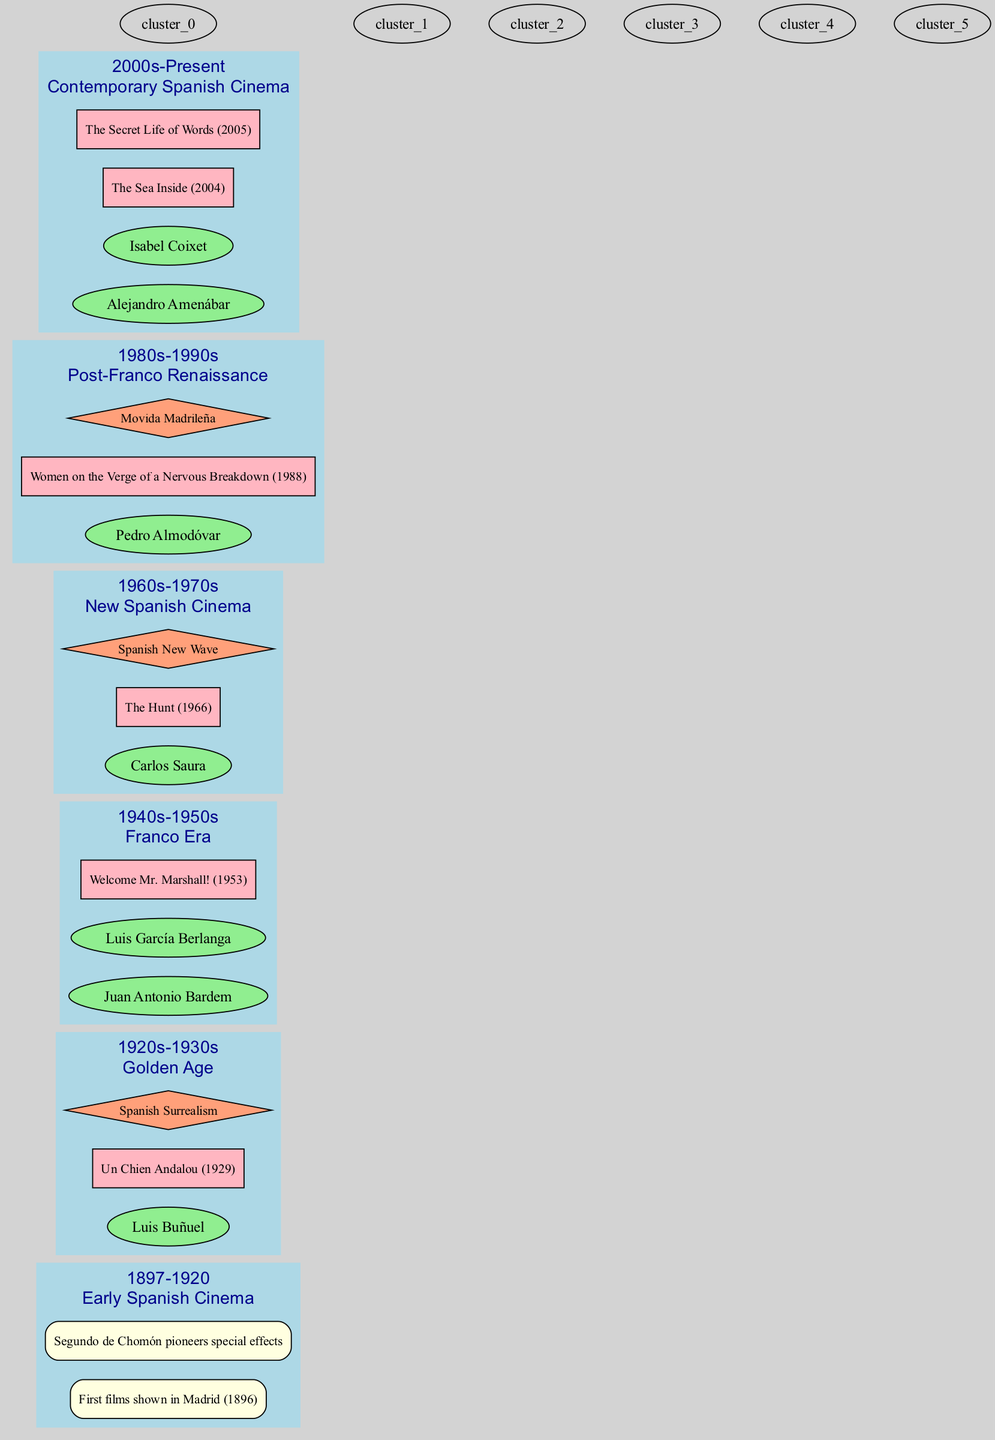What's the label of the cluster for the 1920s-1930s era? The label for the cluster corresponding to the 1920s-1930s era is "Golden Age". This is found within the second-era data in the diagram.
Answer: Golden Age Which key event occurred in 1896? According to the timeline, the key event listed for the year 1896 is the "First films shown in Madrid". This is explicitly stated under the Early Spanish Cinema era.
Answer: First films shown in Madrid How many directors are mentioned in the Franco Era? In the Franco Era (1940s-1950s), there are two directors listed: Juan Antonio Bardem and Luis García Berlanga. Therefore, the count is two.
Answer: 2 What film is associated with Carlos Saura? The film that is associated with Carlos Saura in the New Spanish Cinema era is "The Hunt". This is clearly identified under his section in the diagram.
Answer: The Hunt Which movement is related to the Post-Franco Renaissance? The movement associated with the Post-Franco Renaissance is "Movida Madrileña". This is explicitly noted in the corresponding cluster in the diagram.
Answer: Movida Madrileña How many films are listed for the Contemporary Spanish Cinema era? In the Contemporary Spanish Cinema era, two films are mentioned: "The Sea Inside" and "The Secret Life of Words". Therefore, the total number of films is two.
Answer: 2 Which director is noted for the Spanish Surrealism movement? The director noted for the Spanish Surrealism movement, which occurred during the Golden Age, is Luis Buñuel. This information connects the director to the specific movement in the diagram.
Answer: Luis Buñuel What is the common theme connecting the directors in the Contemporary Spanish Cinema? The common theme among the directors Alejandro Amenábar and Isabel Coixet in this era is their relevance in Contemporary Spanish Cinema. This general overview can be inferred from the diagram.
Answer: Contemporary Spanish Cinema Which cluster includes key events rather than directors or films? The cluster that primarily includes key events is the Early Spanish Cinema era, as it lists significant events instead of directors or films. This clarifies the focus of this particular era in the timeline.
Answer: Early Spanish Cinema 